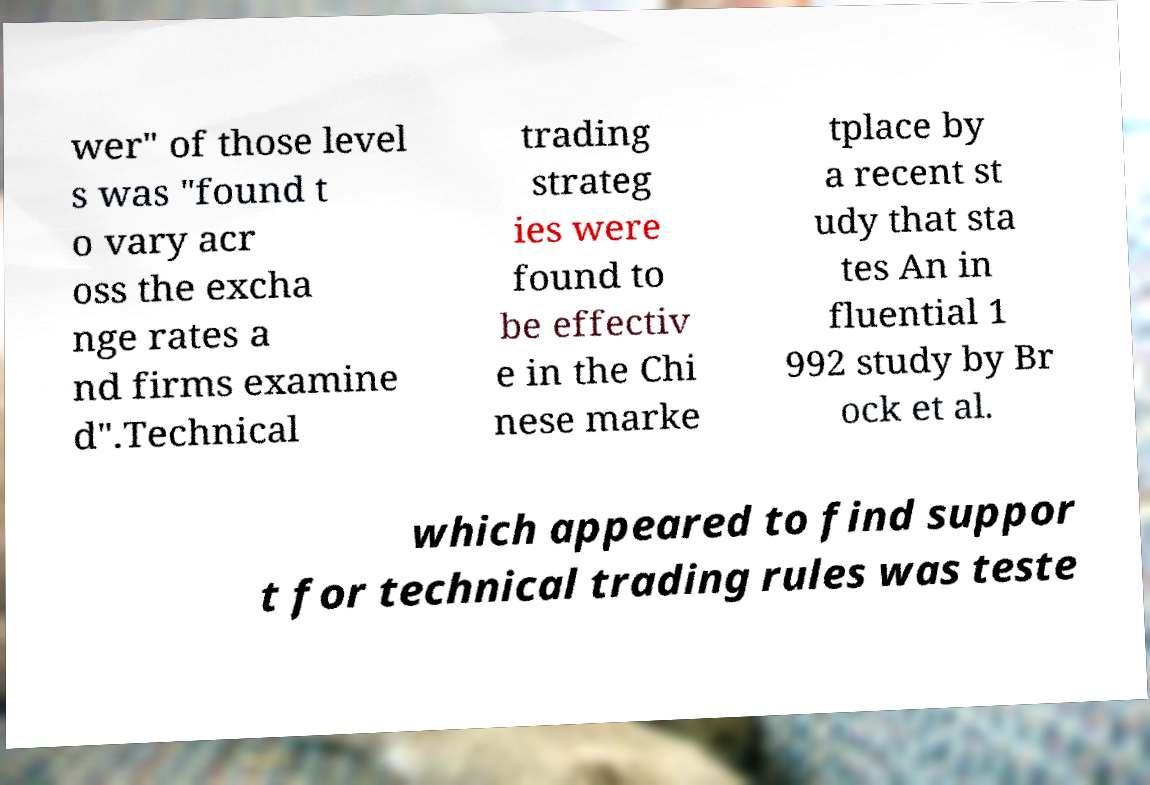I need the written content from this picture converted into text. Can you do that? wer" of those level s was "found t o vary acr oss the excha nge rates a nd firms examine d".Technical trading strateg ies were found to be effectiv e in the Chi nese marke tplace by a recent st udy that sta tes An in fluential 1 992 study by Br ock et al. which appeared to find suppor t for technical trading rules was teste 